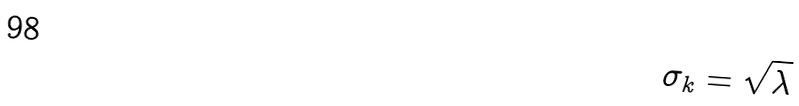Convert formula to latex. <formula><loc_0><loc_0><loc_500><loc_500>\sigma _ { k } = \sqrt { \lambda }</formula> 